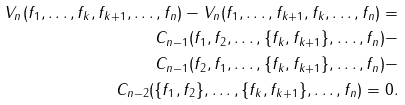Convert formula to latex. <formula><loc_0><loc_0><loc_500><loc_500>V _ { n } ( f _ { 1 } , \dots , f _ { k } , f _ { k + 1 } , \dots , f _ { n } ) - V _ { n } ( f _ { 1 } , \dots , f _ { k + 1 } , f _ { k } , \dots , f _ { n } ) = \\ C _ { n - 1 } ( f _ { 1 } , f _ { 2 } , \dots , \{ f _ { k } , f _ { k + 1 } \} , \dots , f _ { n } ) - \\ C _ { n - 1 } ( f _ { 2 } , f _ { 1 } , \dots , \{ f _ { k } , f _ { k + 1 } \} , \dots , f _ { n } ) - \\ C _ { n - 2 } ( \{ f _ { 1 } , f _ { 2 } \} , \dots , \{ f _ { k } , f _ { k + 1 } \} , \dots , f _ { n } ) = 0 .</formula> 